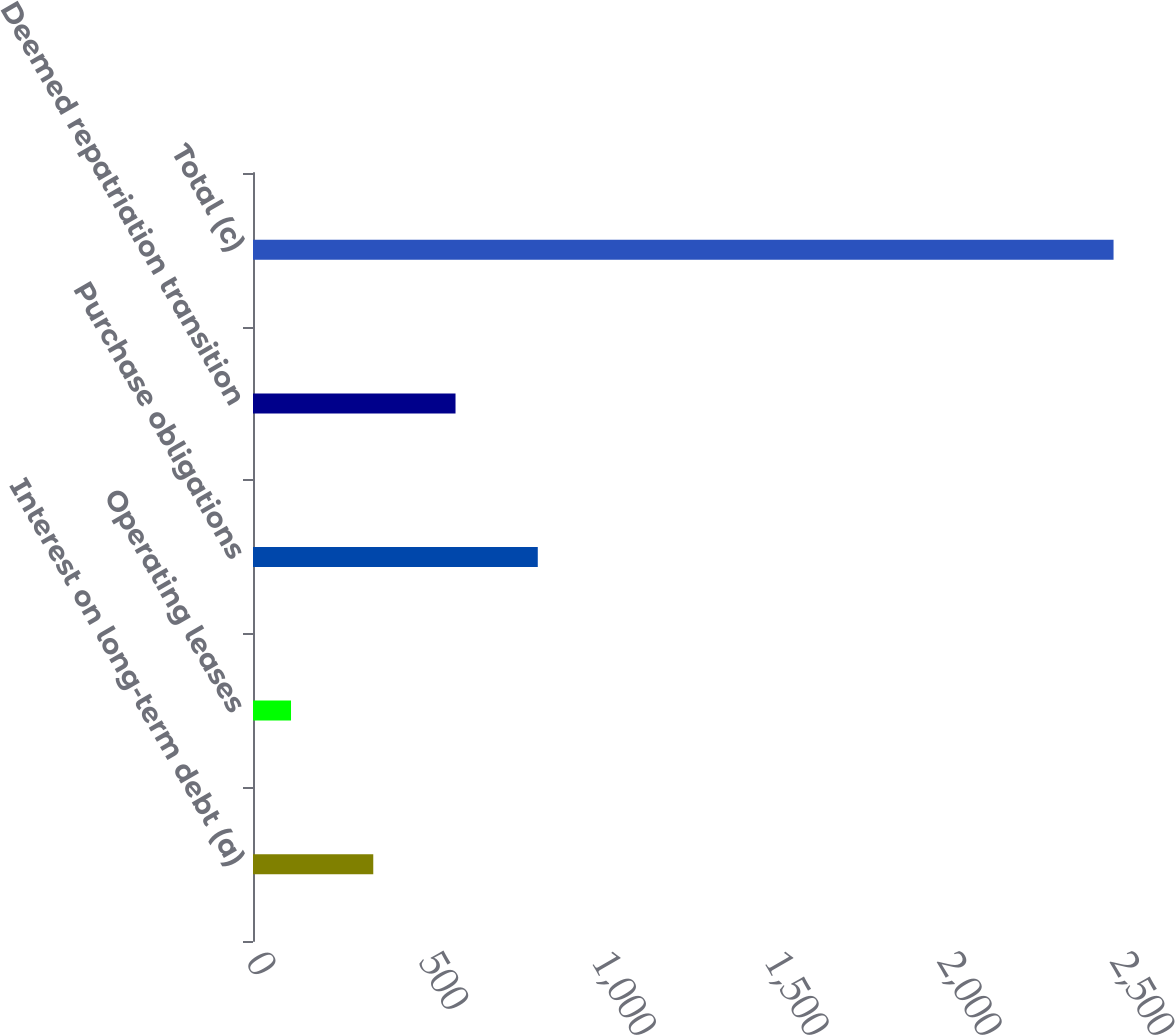Convert chart to OTSL. <chart><loc_0><loc_0><loc_500><loc_500><bar_chart><fcel>Interest on long-term debt (a)<fcel>Operating leases<fcel>Purchase obligations<fcel>Deemed repatriation transition<fcel>Total (c)<nl><fcel>348<fcel>110<fcel>824<fcel>586<fcel>2490<nl></chart> 